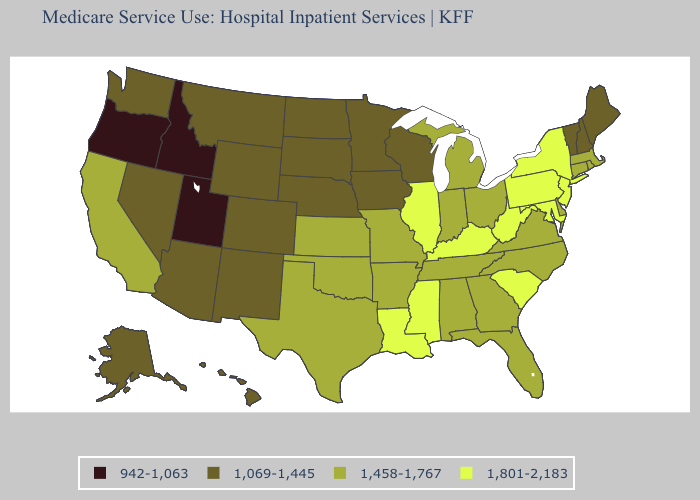Name the states that have a value in the range 1,458-1,767?
Short answer required. Alabama, Arkansas, California, Connecticut, Delaware, Florida, Georgia, Indiana, Kansas, Massachusetts, Michigan, Missouri, North Carolina, Ohio, Oklahoma, Rhode Island, Tennessee, Texas, Virginia. What is the highest value in states that border California?
Concise answer only. 1,069-1,445. Name the states that have a value in the range 1,069-1,445?
Give a very brief answer. Alaska, Arizona, Colorado, Hawaii, Iowa, Maine, Minnesota, Montana, Nebraska, Nevada, New Hampshire, New Mexico, North Dakota, South Dakota, Vermont, Washington, Wisconsin, Wyoming. Does the first symbol in the legend represent the smallest category?
Keep it brief. Yes. What is the value of Tennessee?
Be succinct. 1,458-1,767. Is the legend a continuous bar?
Give a very brief answer. No. Does the first symbol in the legend represent the smallest category?
Be succinct. Yes. Name the states that have a value in the range 942-1,063?
Be succinct. Idaho, Oregon, Utah. Name the states that have a value in the range 1,069-1,445?
Short answer required. Alaska, Arizona, Colorado, Hawaii, Iowa, Maine, Minnesota, Montana, Nebraska, Nevada, New Hampshire, New Mexico, North Dakota, South Dakota, Vermont, Washington, Wisconsin, Wyoming. What is the value of Hawaii?
Answer briefly. 1,069-1,445. Does Utah have a higher value than Montana?
Concise answer only. No. Does California have the highest value in the USA?
Quick response, please. No. Does California have the highest value in the West?
Quick response, please. Yes. Does Missouri have a lower value than Colorado?
Keep it brief. No. Which states have the highest value in the USA?
Give a very brief answer. Illinois, Kentucky, Louisiana, Maryland, Mississippi, New Jersey, New York, Pennsylvania, South Carolina, West Virginia. 